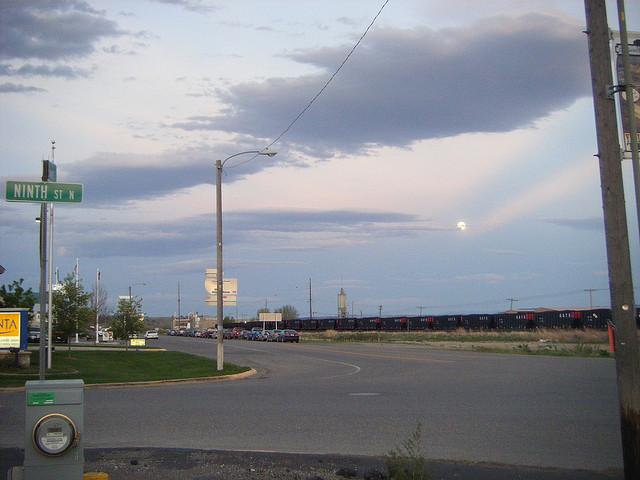How many street lights can be seen?
Answer briefly. 1. What is the color of the cloud?
Answer briefly. Gray. Is there parking on the street?
Keep it brief. No. What is the name of the street depicted in the picture?
Short answer required. Ninth. Is the sun shining?
Short answer required. No. What color is the sign?
Write a very short answer. Green. 